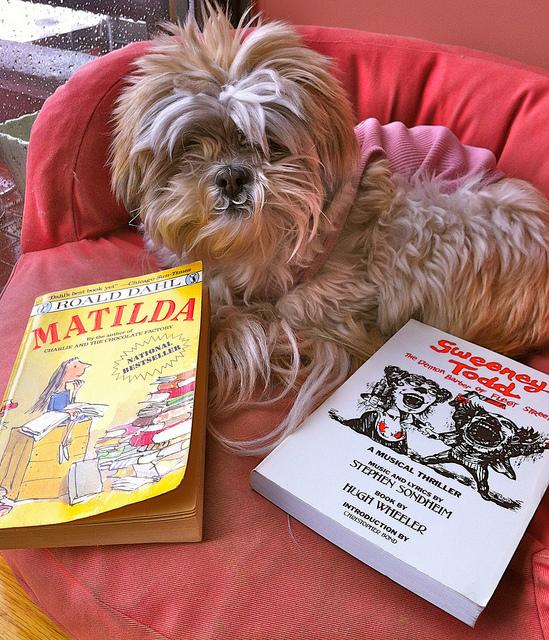What book is on the left?
Write a very short answer. Matilda. How many books do you see?
Concise answer only. 2. What color is the chair cover?
Quick response, please. Red. 